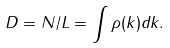Convert formula to latex. <formula><loc_0><loc_0><loc_500><loc_500>D = N / L = \int \rho ( k ) d k .</formula> 